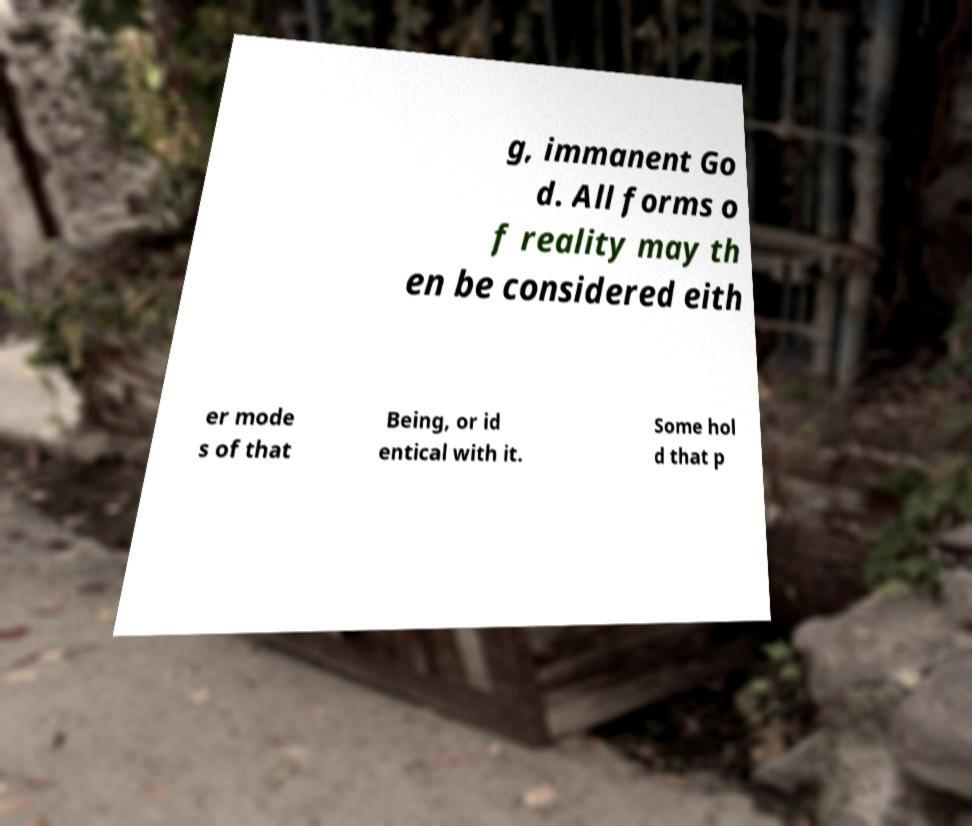There's text embedded in this image that I need extracted. Can you transcribe it verbatim? g, immanent Go d. All forms o f reality may th en be considered eith er mode s of that Being, or id entical with it. Some hol d that p 